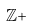<formula> <loc_0><loc_0><loc_500><loc_500>\mathbb { Z } +</formula> 